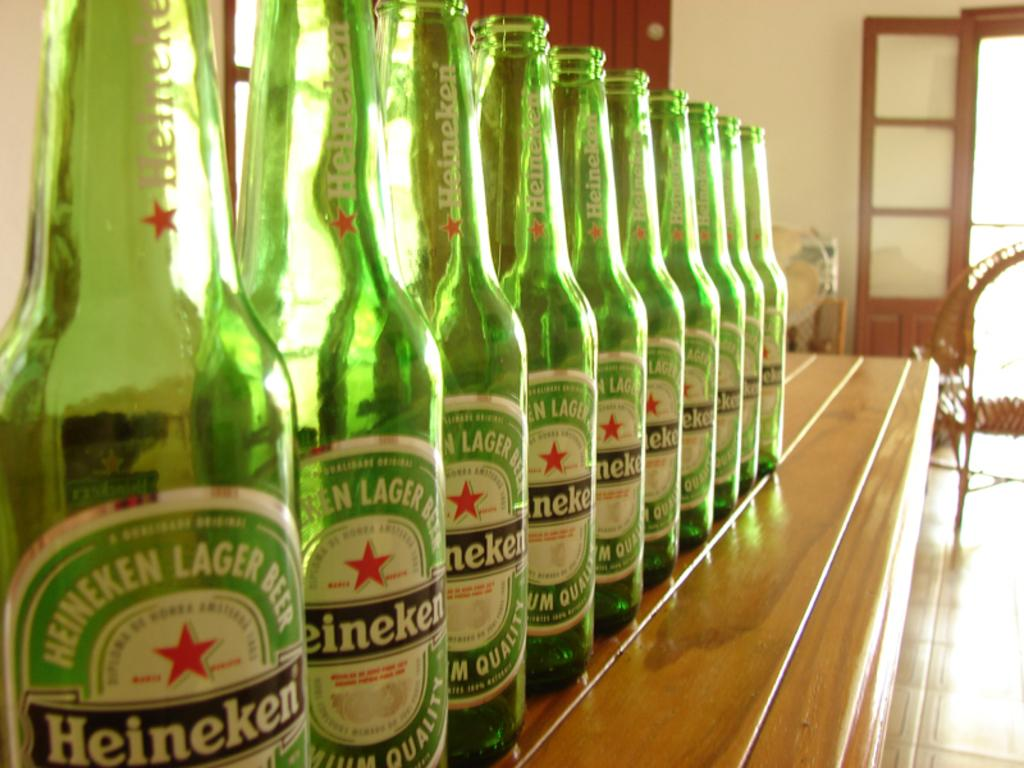<image>
Provide a brief description of the given image. Several empty bottles of Heineken are sitting in a row on top of a bar. 